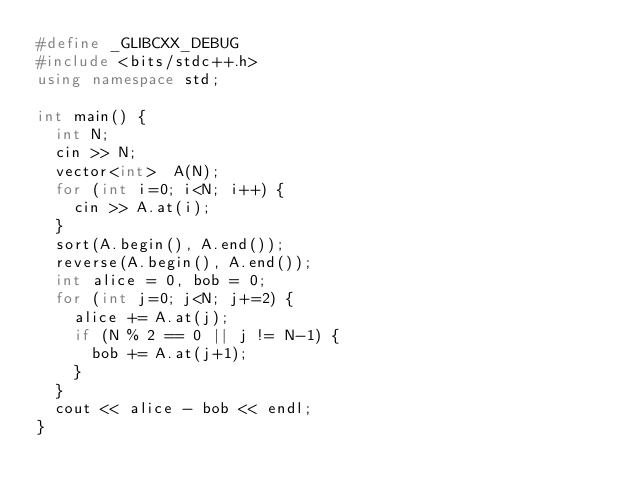Convert code to text. <code><loc_0><loc_0><loc_500><loc_500><_C++_>#define _GLIBCXX_DEBUG
#include <bits/stdc++.h>
using namespace std;

int main() {
  int N;
  cin >> N;
  vector<int>  A(N);
  for (int i=0; i<N; i++) {
    cin >> A.at(i);
  }
  sort(A.begin(), A.end());
  reverse(A.begin(), A.end());
  int alice = 0, bob = 0;
  for (int j=0; j<N; j+=2) {
    alice += A.at(j);
    if (N % 2 == 0 || j != N-1) {
      bob += A.at(j+1);
    }
  }
  cout << alice - bob << endl;
}
</code> 